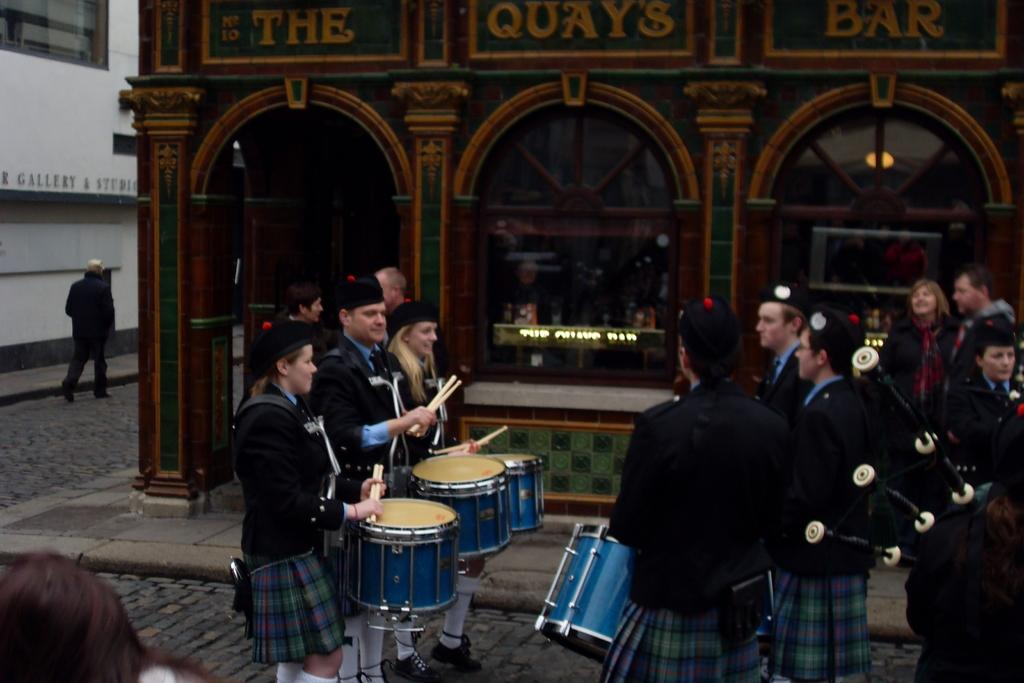What activity are the people in the image engaged in? The people in the image are playing drums. Can you describe the gender of the individuals in the image? There are men and women in the image. What can be seen in the background of the image? There is a building in the background of the image. What type of trail can be seen in the image? There is no trail present in the image; it features people playing drums. How many train cars can be seen in the image? There is no train present in the image; it features people playing drums. 